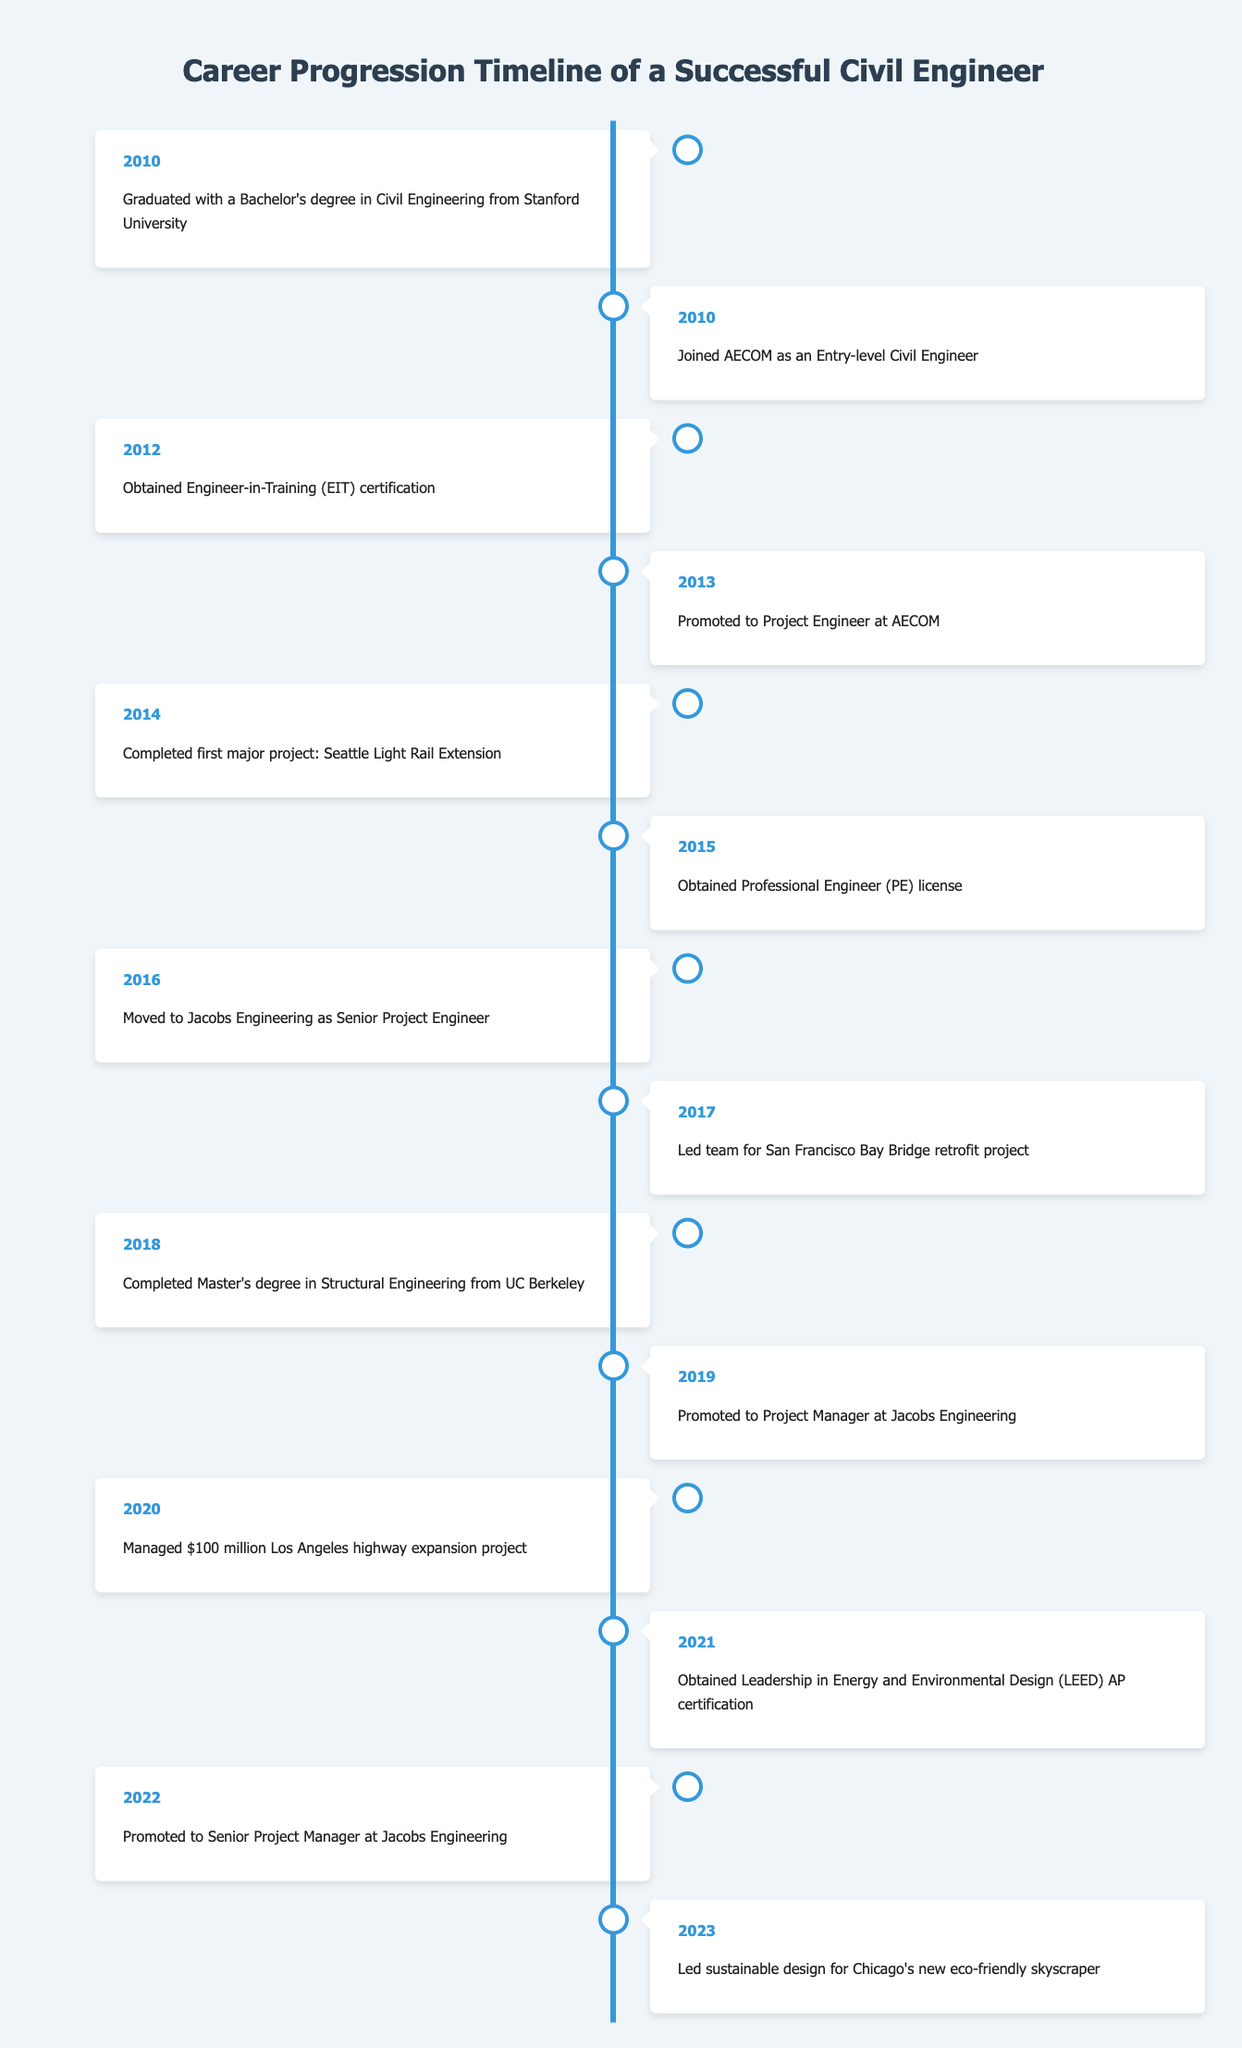What year did the engineer graduate? According to the table, the engineer graduated with a Bachelor's degree in Civil Engineering in 2010.
Answer: 2010 How many years passed between obtaining the EIT certification and becoming a Project Engineer? The engineer obtained the Engineer-in-Training (EIT) certification in 2012 and was promoted to Project Engineer in 2013. Therefore, there is a 1-year difference.
Answer: 1 year Did the engineer earn a Professional Engineer (PE) license before moving to Jacobs Engineering? The table shows that the engineer obtained the Professional Engineer (PE) license in 2015, and moved to Jacobs Engineering in 2016. Thus, the answer is yes.
Answer: Yes What was the first major project completed by the engineer, and in what year? The first major project completed by the engineer was the Seattle Light Rail Extension, which was completed in 2014.
Answer: Seattle Light Rail Extension, 2014 How many total years of experience did the engineer have by 2022? The engineer graduated in 2010 and was promoted to Senior Project Manager in 2022. Therefore, from 2010 to 2022 is a total of 12 years of experience.
Answer: 12 years What is the difference in years between obtaining the Master's degree and being promoted to Senior Project Manager? The engineer completed the Master's degree in 2018 and was promoted to Senior Project Manager in 2022. The difference is 2022 - 2018 = 4 years.
Answer: 4 years Did the engineer lead a project related to sustainable design? The table indicates that in 2023, the engineer led sustainable design for Chicago's new eco-friendly skyscraper. Thus, the answer is yes.
Answer: Yes What is the duration of time between the first project completion and the management of the Los Angeles highway expansion project? The engineer completed their first major project in 2014 and managed the Los Angeles highway expansion project in 2020. The difference is 2020 - 2014 = 6 years.
Answer: 6 years How many significant promotions did the engineer achieve from 2013 to 2022? From 2013 to 2022, the engineer was promoted to Project Engineer in 2013, Project Manager in 2019, and Senior Project Manager in 2022. Therefore, there were 3 promotions during that period.
Answer: 3 promotions 